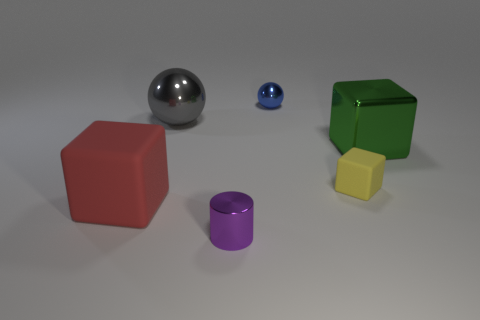Add 3 small yellow things. How many objects exist? 9 Subtract all cylinders. How many objects are left? 5 Add 6 blue shiny balls. How many blue shiny balls exist? 7 Subtract 0 green cylinders. How many objects are left? 6 Subtract all small yellow blocks. Subtract all big gray rubber cylinders. How many objects are left? 5 Add 4 green metal objects. How many green metal objects are left? 5 